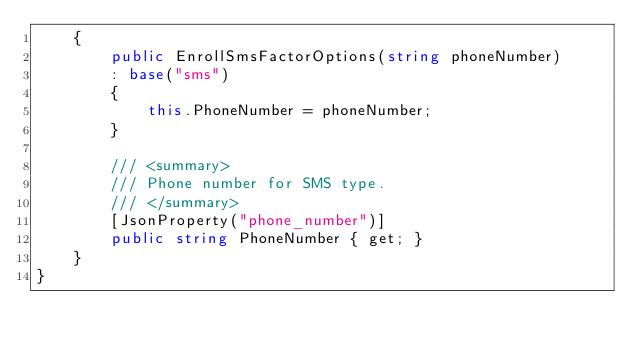Convert code to text. <code><loc_0><loc_0><loc_500><loc_500><_C#_>    {
        public EnrollSmsFactorOptions(string phoneNumber)
        : base("sms")
        {
            this.PhoneNumber = phoneNumber;
        }

        /// <summary>
        /// Phone number for SMS type.
        /// </summary>
        [JsonProperty("phone_number")]
        public string PhoneNumber { get; }
    }
}
</code> 